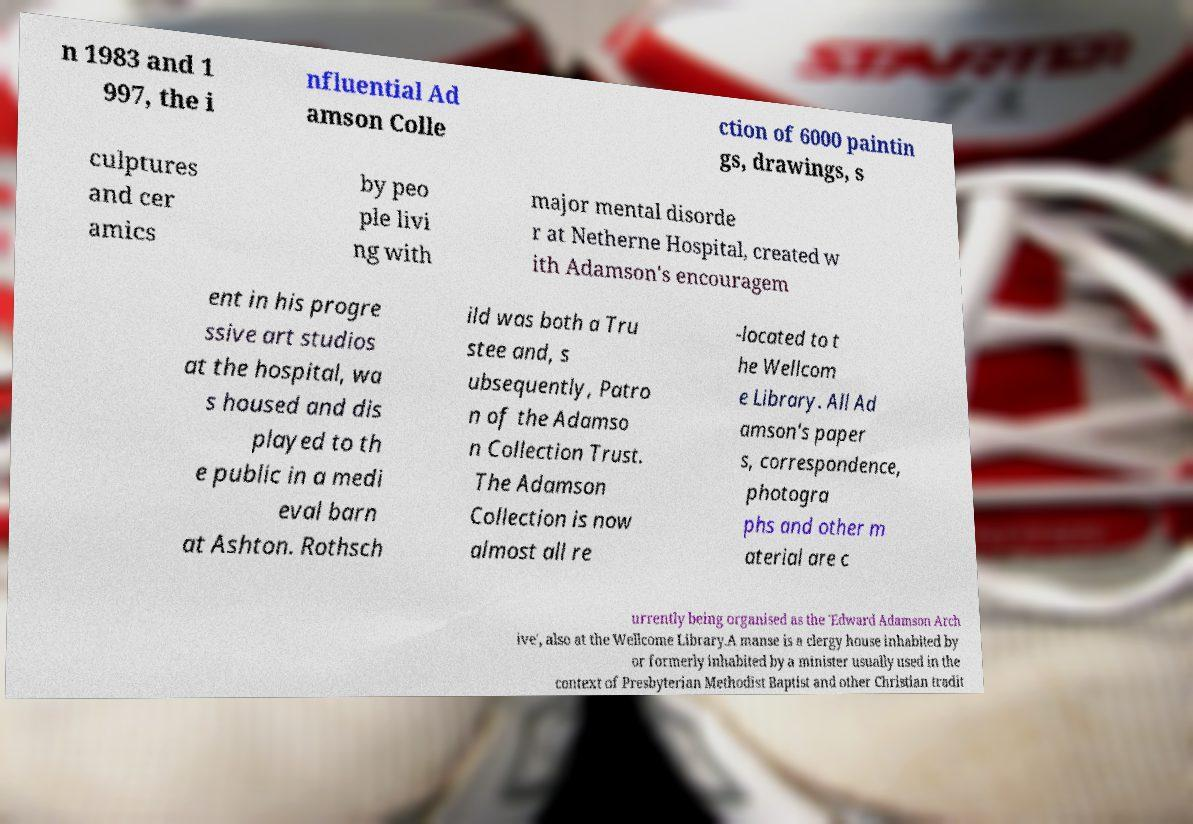For documentation purposes, I need the text within this image transcribed. Could you provide that? n 1983 and 1 997, the i nfluential Ad amson Colle ction of 6000 paintin gs, drawings, s culptures and cer amics by peo ple livi ng with major mental disorde r at Netherne Hospital, created w ith Adamson's encouragem ent in his progre ssive art studios at the hospital, wa s housed and dis played to th e public in a medi eval barn at Ashton. Rothsch ild was both a Tru stee and, s ubsequently, Patro n of the Adamso n Collection Trust. The Adamson Collection is now almost all re -located to t he Wellcom e Library. All Ad amson's paper s, correspondence, photogra phs and other m aterial are c urrently being organised as the 'Edward Adamson Arch ive', also at the Wellcome Library.A manse is a clergy house inhabited by or formerly inhabited by a minister usually used in the context of Presbyterian Methodist Baptist and other Christian tradit 